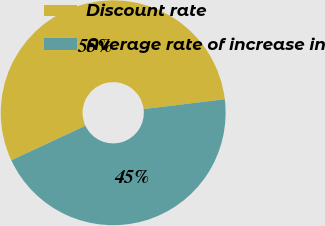<chart> <loc_0><loc_0><loc_500><loc_500><pie_chart><fcel>Discount rate<fcel>Average rate of increase in<nl><fcel>55.03%<fcel>44.97%<nl></chart> 